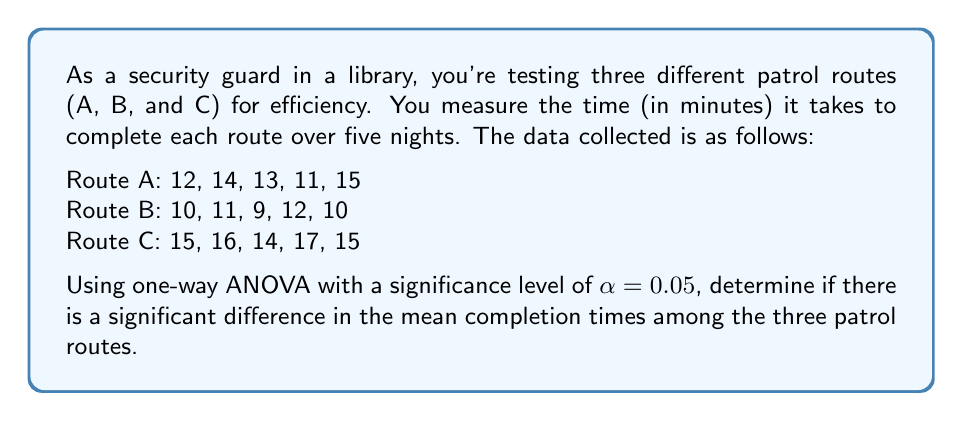Teach me how to tackle this problem. To solve this problem, we'll follow these steps:

1) First, let's calculate the sum, mean, and sum of squares for each group:

   Route A: $\sum X_A = 65$, $\bar{X}_A = 13$, $\sum X_A^2 = 853$
   Route B: $\sum X_B = 52$, $\bar{X}_B = 10.4$, $\sum X_B^2 = 546$
   Route C: $\sum X_C = 77$, $\bar{X}_C = 15.4$, $\sum X_C^2 = 1195$

2) Calculate the total sum of squares (SST):
   $$SST = \sum X_A^2 + \sum X_B^2 + \sum X_C^2 - \frac{(\sum X_A + \sum X_B + \sum X_C)^2}{N}$$
   $$SST = 853 + 546 + 1195 - \frac{(65 + 52 + 77)^2}{15} = 104.4$$

3) Calculate the between-group sum of squares (SSB):
   $$SSB = \frac{\sum X_A^2}{n_A} + \frac{\sum X_B^2}{n_B} + \frac{\sum X_C^2}{n_C} - \frac{(\sum X_A + \sum X_B + \sum X_C)^2}{N}$$
   $$SSB = \frac{65^2}{5} + \frac{52^2}{5} + \frac{77^2}{5} - \frac{194^2}{15} = 84.4$$

4) Calculate the within-group sum of squares (SSW):
   $$SSW = SST - SSB = 104.4 - 84.4 = 20$$

5) Determine the degrees of freedom:
   $df_{between} = k - 1 = 3 - 1 = 2$ (where k is the number of groups)
   $df_{within} = N - k = 15 - 3 = 12$ (where N is the total number of observations)

6) Calculate the mean squares:
   $$MS_{between} = \frac{SSB}{df_{between}} = \frac{84.4}{2} = 42.2$$
   $$MS_{within} = \frac{SSW}{df_{within}} = \frac{20}{12} = 1.67$$

7) Calculate the F-statistic:
   $$F = \frac{MS_{between}}{MS_{within}} = \frac{42.2}{1.67} = 25.27$$

8) Find the critical F-value:
   For $\alpha = 0.05$, $df_{between} = 2$, and $df_{within} = 12$, the critical F-value is approximately 3.89.

9) Compare the calculated F-statistic to the critical F-value:
   Since $25.27 > 3.89$, we reject the null hypothesis.
Answer: The F-statistic (25.27) is greater than the critical F-value (3.89), so we reject the null hypothesis. There is significant evidence to conclude that there are differences in the mean completion times among the three patrol routes at the 0.05 significance level. 